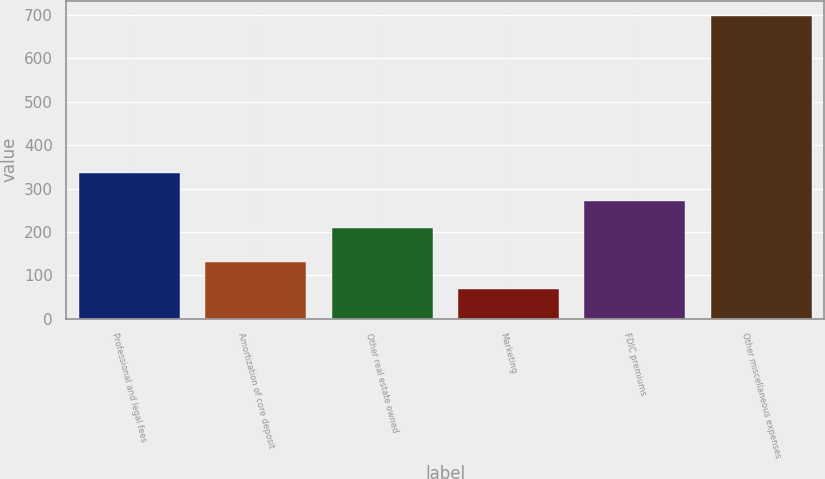<chart> <loc_0><loc_0><loc_500><loc_500><bar_chart><fcel>Professional and legal fees<fcel>Amortization of core deposit<fcel>Other real estate owned<fcel>Marketing<fcel>FDIC premiums<fcel>Other miscellaneous expenses<nl><fcel>335<fcel>131<fcel>209<fcel>68<fcel>272<fcel>698<nl></chart> 